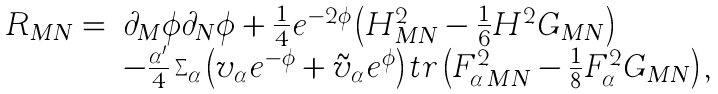Convert formula to latex. <formula><loc_0><loc_0><loc_500><loc_500>\begin{array} { l l } R _ { M N } = & \partial _ { M } \phi \partial _ { N } \phi + \frac { 1 } { 4 } e ^ { - 2 \phi } \left ( H ^ { 2 } _ { M N } - \frac { 1 } { 6 } H ^ { 2 } G _ { M N } \right ) \\ & - \frac { \alpha ^ { \prime } } { 4 } \sum _ { \alpha } \left ( v _ { \alpha } e ^ { - \phi } + \tilde { v } _ { \alpha } e ^ { \phi } \right ) t r \left ( F _ { \alpha \, M N } ^ { 2 } - \frac { 1 } { 8 } F _ { \alpha } ^ { 2 } G _ { M N } \right ) , \end{array}</formula> 